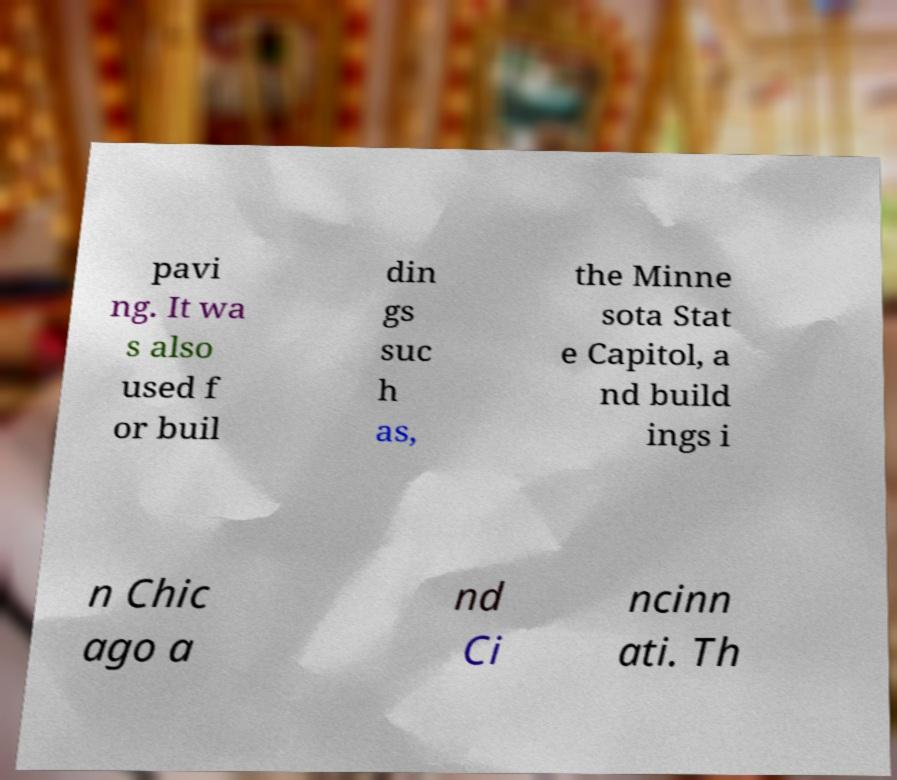I need the written content from this picture converted into text. Can you do that? pavi ng. It wa s also used f or buil din gs suc h as, the Minne sota Stat e Capitol, a nd build ings i n Chic ago a nd Ci ncinn ati. Th 